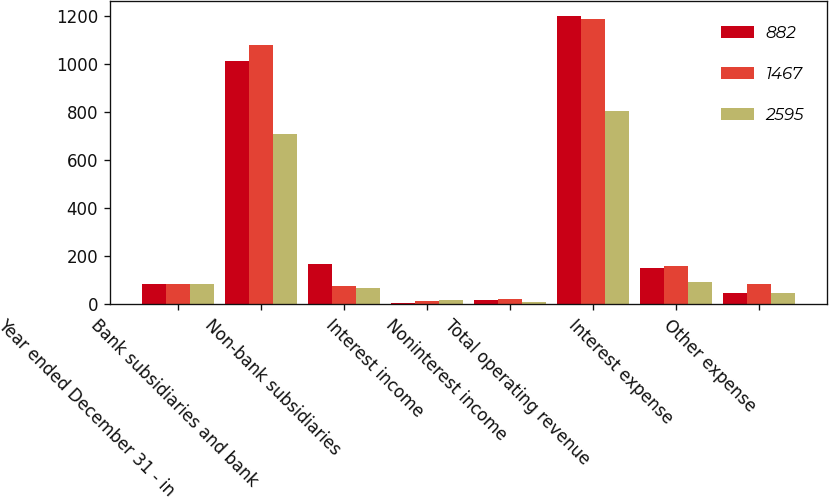Convert chart to OTSL. <chart><loc_0><loc_0><loc_500><loc_500><stacked_bar_chart><ecel><fcel>Year ended December 31 - in<fcel>Bank subsidiaries and bank<fcel>Non-bank subsidiaries<fcel>Interest income<fcel>Noninterest income<fcel>Total operating revenue<fcel>Interest expense<fcel>Other expense<nl><fcel>882<fcel>84<fcel>1012<fcel>168<fcel>4<fcel>18<fcel>1202<fcel>152<fcel>46<nl><fcel>1467<fcel>84<fcel>1078<fcel>74<fcel>15<fcel>23<fcel>1190<fcel>160<fcel>84<nl><fcel>2595<fcel>84<fcel>710<fcel>69<fcel>16<fcel>9<fcel>804<fcel>93<fcel>46<nl></chart> 